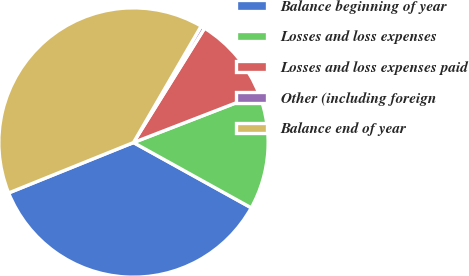<chart> <loc_0><loc_0><loc_500><loc_500><pie_chart><fcel>Balance beginning of year<fcel>Losses and loss expenses<fcel>Losses and loss expenses paid<fcel>Other (including foreign<fcel>Balance end of year<nl><fcel>35.84%<fcel>13.93%<fcel>10.27%<fcel>0.48%<fcel>39.49%<nl></chart> 